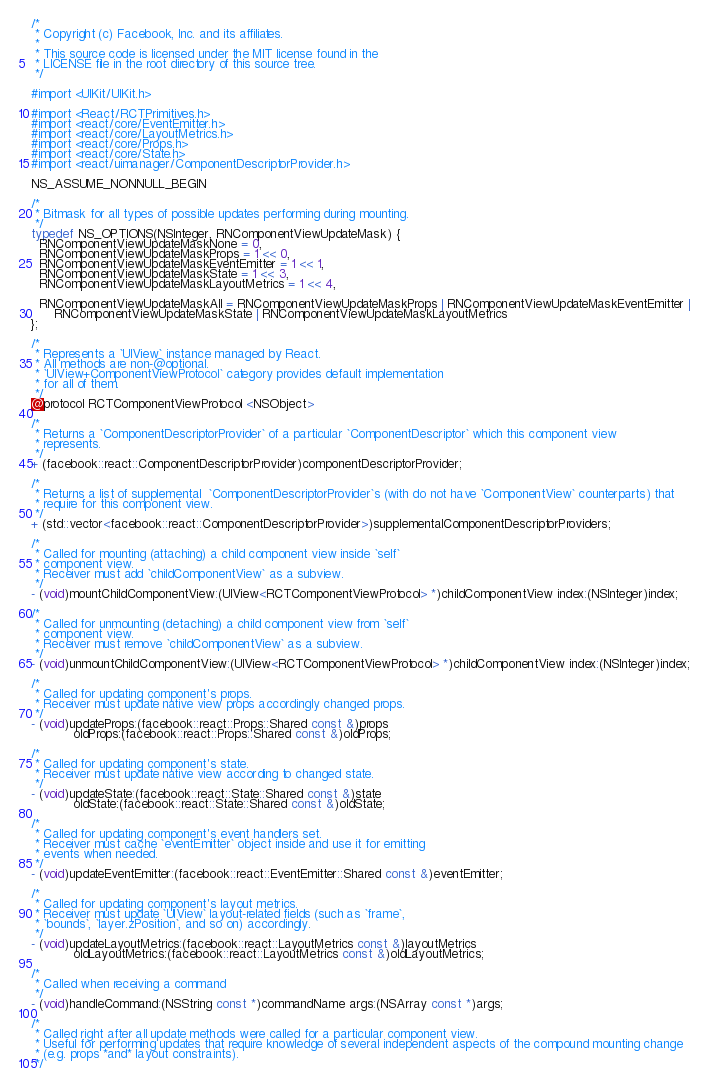<code> <loc_0><loc_0><loc_500><loc_500><_C_>/*
 * Copyright (c) Facebook, Inc. and its affiliates.
 *
 * This source code is licensed under the MIT license found in the
 * LICENSE file in the root directory of this source tree.
 */

#import <UIKit/UIKit.h>

#import <React/RCTPrimitives.h>
#import <react/core/EventEmitter.h>
#import <react/core/LayoutMetrics.h>
#import <react/core/Props.h>
#import <react/core/State.h>
#import <react/uimanager/ComponentDescriptorProvider.h>

NS_ASSUME_NONNULL_BEGIN

/*
 * Bitmask for all types of possible updates performing during mounting.
 */
typedef NS_OPTIONS(NSInteger, RNComponentViewUpdateMask) {
  RNComponentViewUpdateMaskNone = 0,
  RNComponentViewUpdateMaskProps = 1 << 0,
  RNComponentViewUpdateMaskEventEmitter = 1 << 1,
  RNComponentViewUpdateMaskState = 1 << 3,
  RNComponentViewUpdateMaskLayoutMetrics = 1 << 4,

  RNComponentViewUpdateMaskAll = RNComponentViewUpdateMaskProps | RNComponentViewUpdateMaskEventEmitter |
      RNComponentViewUpdateMaskState | RNComponentViewUpdateMaskLayoutMetrics
};

/*
 * Represents a `UIView` instance managed by React.
 * All methods are non-@optional.
 * `UIView+ComponentViewProtocol` category provides default implementation
 * for all of them.
 */
@protocol RCTComponentViewProtocol <NSObject>

/*
 * Returns a `ComponentDescriptorProvider` of a particular `ComponentDescriptor` which this component view
 * represents.
 */
+ (facebook::react::ComponentDescriptorProvider)componentDescriptorProvider;

/*
 * Returns a list of supplemental  `ComponentDescriptorProvider`s (with do not have `ComponentView` counterparts) that
 * require for this component view.
 */
+ (std::vector<facebook::react::ComponentDescriptorProvider>)supplementalComponentDescriptorProviders;

/*
 * Called for mounting (attaching) a child component view inside `self`
 * component view.
 * Receiver must add `childComponentView` as a subview.
 */
- (void)mountChildComponentView:(UIView<RCTComponentViewProtocol> *)childComponentView index:(NSInteger)index;

/*
 * Called for unmounting (detaching) a child component view from `self`
 * component view.
 * Receiver must remove `childComponentView` as a subview.
 */
- (void)unmountChildComponentView:(UIView<RCTComponentViewProtocol> *)childComponentView index:(NSInteger)index;

/*
 * Called for updating component's props.
 * Receiver must update native view props accordingly changed props.
 */
- (void)updateProps:(facebook::react::Props::Shared const &)props
           oldProps:(facebook::react::Props::Shared const &)oldProps;

/*
 * Called for updating component's state.
 * Receiver must update native view according to changed state.
 */
- (void)updateState:(facebook::react::State::Shared const &)state
           oldState:(facebook::react::State::Shared const &)oldState;

/*
 * Called for updating component's event handlers set.
 * Receiver must cache `eventEmitter` object inside and use it for emitting
 * events when needed.
 */
- (void)updateEventEmitter:(facebook::react::EventEmitter::Shared const &)eventEmitter;

/*
 * Called for updating component's layout metrics.
 * Receiver must update `UIView` layout-related fields (such as `frame`,
 * `bounds`, `layer.zPosition`, and so on) accordingly.
 */
- (void)updateLayoutMetrics:(facebook::react::LayoutMetrics const &)layoutMetrics
           oldLayoutMetrics:(facebook::react::LayoutMetrics const &)oldLayoutMetrics;

/*
 * Called when receiving a command
 */
- (void)handleCommand:(NSString const *)commandName args:(NSArray const *)args;

/*
 * Called right after all update methods were called for a particular component view.
 * Useful for performing updates that require knowledge of several independent aspects of the compound mounting change
 * (e.g. props *and* layout constraints).
 */</code> 